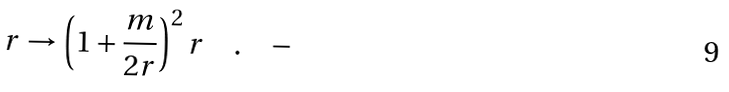Convert formula to latex. <formula><loc_0><loc_0><loc_500><loc_500>r \rightarrow \left ( 1 + \frac { m } { 2 r } \right ) ^ { 2 } r \quad . \quad -</formula> 